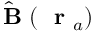Convert formula to latex. <formula><loc_0><loc_0><loc_500><loc_500>\hat { B } ( r _ { a } )</formula> 